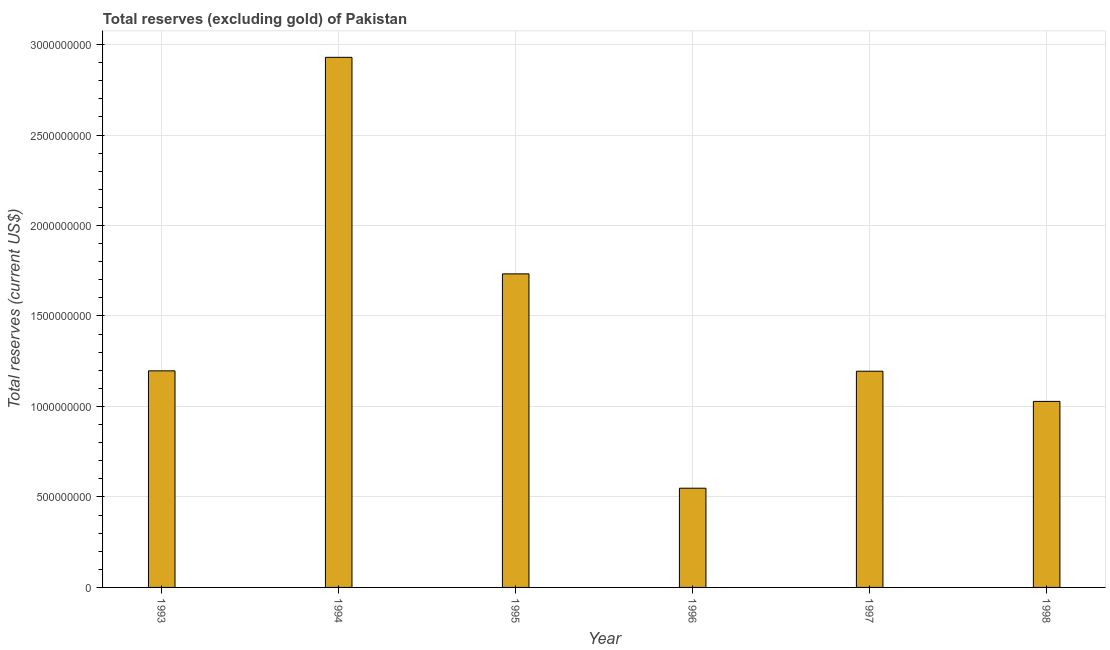Does the graph contain any zero values?
Your answer should be compact. No. What is the title of the graph?
Provide a short and direct response. Total reserves (excluding gold) of Pakistan. What is the label or title of the X-axis?
Ensure brevity in your answer.  Year. What is the label or title of the Y-axis?
Offer a very short reply. Total reserves (current US$). What is the total reserves (excluding gold) in 1997?
Give a very brief answer. 1.19e+09. Across all years, what is the maximum total reserves (excluding gold)?
Your response must be concise. 2.93e+09. Across all years, what is the minimum total reserves (excluding gold)?
Give a very brief answer. 5.48e+08. In which year was the total reserves (excluding gold) maximum?
Give a very brief answer. 1994. In which year was the total reserves (excluding gold) minimum?
Provide a short and direct response. 1996. What is the sum of the total reserves (excluding gold)?
Your answer should be very brief. 8.63e+09. What is the difference between the total reserves (excluding gold) in 1996 and 1997?
Make the answer very short. -6.47e+08. What is the average total reserves (excluding gold) per year?
Make the answer very short. 1.44e+09. What is the median total reserves (excluding gold)?
Provide a short and direct response. 1.20e+09. What is the ratio of the total reserves (excluding gold) in 1994 to that in 1998?
Keep it short and to the point. 2.85. What is the difference between the highest and the second highest total reserves (excluding gold)?
Give a very brief answer. 1.20e+09. Is the sum of the total reserves (excluding gold) in 1994 and 1997 greater than the maximum total reserves (excluding gold) across all years?
Your response must be concise. Yes. What is the difference between the highest and the lowest total reserves (excluding gold)?
Keep it short and to the point. 2.38e+09. In how many years, is the total reserves (excluding gold) greater than the average total reserves (excluding gold) taken over all years?
Your answer should be compact. 2. How many bars are there?
Offer a very short reply. 6. What is the Total reserves (current US$) in 1993?
Provide a succinct answer. 1.20e+09. What is the Total reserves (current US$) in 1994?
Make the answer very short. 2.93e+09. What is the Total reserves (current US$) of 1995?
Your answer should be very brief. 1.73e+09. What is the Total reserves (current US$) in 1996?
Make the answer very short. 5.48e+08. What is the Total reserves (current US$) in 1997?
Provide a short and direct response. 1.19e+09. What is the Total reserves (current US$) of 1998?
Give a very brief answer. 1.03e+09. What is the difference between the Total reserves (current US$) in 1993 and 1994?
Ensure brevity in your answer.  -1.73e+09. What is the difference between the Total reserves (current US$) in 1993 and 1995?
Your answer should be very brief. -5.36e+08. What is the difference between the Total reserves (current US$) in 1993 and 1996?
Make the answer very short. 6.49e+08. What is the difference between the Total reserves (current US$) in 1993 and 1997?
Provide a short and direct response. 1.96e+06. What is the difference between the Total reserves (current US$) in 1993 and 1998?
Your answer should be compact. 1.69e+08. What is the difference between the Total reserves (current US$) in 1994 and 1995?
Your answer should be very brief. 1.20e+09. What is the difference between the Total reserves (current US$) in 1994 and 1996?
Give a very brief answer. 2.38e+09. What is the difference between the Total reserves (current US$) in 1994 and 1997?
Give a very brief answer. 1.73e+09. What is the difference between the Total reserves (current US$) in 1994 and 1998?
Give a very brief answer. 1.90e+09. What is the difference between the Total reserves (current US$) in 1995 and 1996?
Your response must be concise. 1.18e+09. What is the difference between the Total reserves (current US$) in 1995 and 1997?
Offer a very short reply. 5.38e+08. What is the difference between the Total reserves (current US$) in 1995 and 1998?
Provide a short and direct response. 7.05e+08. What is the difference between the Total reserves (current US$) in 1996 and 1997?
Your answer should be very brief. -6.47e+08. What is the difference between the Total reserves (current US$) in 1996 and 1998?
Ensure brevity in your answer.  -4.80e+08. What is the difference between the Total reserves (current US$) in 1997 and 1998?
Your answer should be compact. 1.67e+08. What is the ratio of the Total reserves (current US$) in 1993 to that in 1994?
Keep it short and to the point. 0.41. What is the ratio of the Total reserves (current US$) in 1993 to that in 1995?
Keep it short and to the point. 0.69. What is the ratio of the Total reserves (current US$) in 1993 to that in 1996?
Give a very brief answer. 2.18. What is the ratio of the Total reserves (current US$) in 1993 to that in 1997?
Your response must be concise. 1. What is the ratio of the Total reserves (current US$) in 1993 to that in 1998?
Provide a short and direct response. 1.16. What is the ratio of the Total reserves (current US$) in 1994 to that in 1995?
Your response must be concise. 1.69. What is the ratio of the Total reserves (current US$) in 1994 to that in 1996?
Your answer should be very brief. 5.34. What is the ratio of the Total reserves (current US$) in 1994 to that in 1997?
Offer a very short reply. 2.45. What is the ratio of the Total reserves (current US$) in 1994 to that in 1998?
Make the answer very short. 2.85. What is the ratio of the Total reserves (current US$) in 1995 to that in 1996?
Ensure brevity in your answer.  3.16. What is the ratio of the Total reserves (current US$) in 1995 to that in 1997?
Your answer should be compact. 1.45. What is the ratio of the Total reserves (current US$) in 1995 to that in 1998?
Ensure brevity in your answer.  1.69. What is the ratio of the Total reserves (current US$) in 1996 to that in 1997?
Ensure brevity in your answer.  0.46. What is the ratio of the Total reserves (current US$) in 1996 to that in 1998?
Provide a short and direct response. 0.53. What is the ratio of the Total reserves (current US$) in 1997 to that in 1998?
Your answer should be compact. 1.16. 